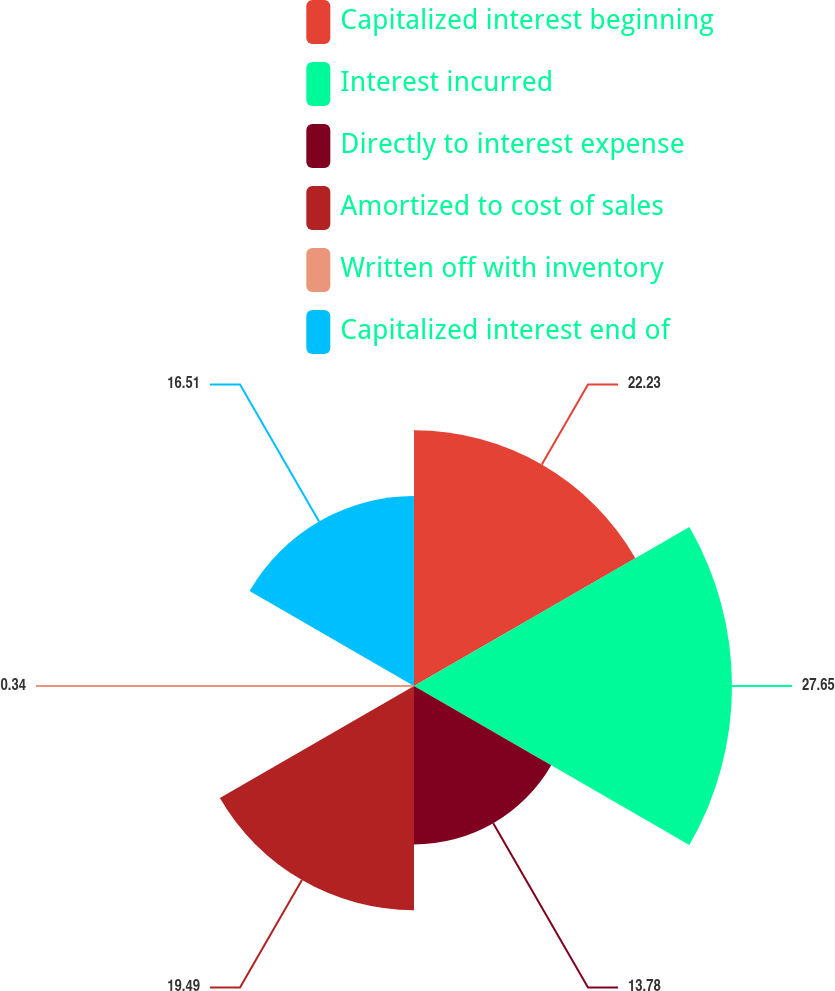Convert chart. <chart><loc_0><loc_0><loc_500><loc_500><pie_chart><fcel>Capitalized interest beginning<fcel>Interest incurred<fcel>Directly to interest expense<fcel>Amortized to cost of sales<fcel>Written off with inventory<fcel>Capitalized interest end of<nl><fcel>22.23%<fcel>27.65%<fcel>13.78%<fcel>19.49%<fcel>0.34%<fcel>16.51%<nl></chart> 